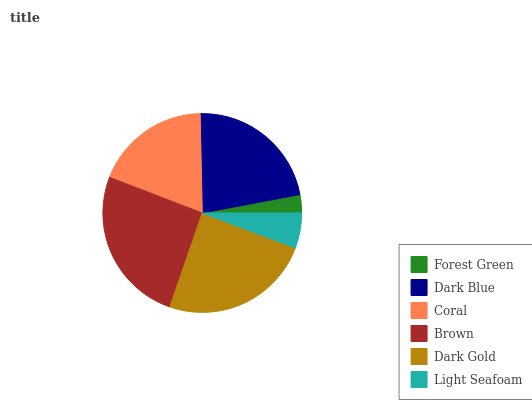Is Forest Green the minimum?
Answer yes or no. Yes. Is Brown the maximum?
Answer yes or no. Yes. Is Dark Blue the minimum?
Answer yes or no. No. Is Dark Blue the maximum?
Answer yes or no. No. Is Dark Blue greater than Forest Green?
Answer yes or no. Yes. Is Forest Green less than Dark Blue?
Answer yes or no. Yes. Is Forest Green greater than Dark Blue?
Answer yes or no. No. Is Dark Blue less than Forest Green?
Answer yes or no. No. Is Dark Blue the high median?
Answer yes or no. Yes. Is Coral the low median?
Answer yes or no. Yes. Is Dark Gold the high median?
Answer yes or no. No. Is Forest Green the low median?
Answer yes or no. No. 